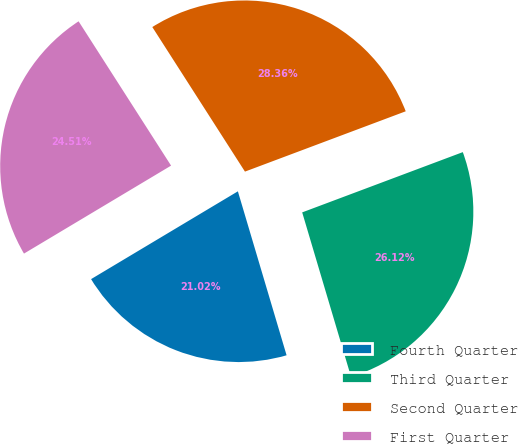Convert chart to OTSL. <chart><loc_0><loc_0><loc_500><loc_500><pie_chart><fcel>Fourth Quarter<fcel>Third Quarter<fcel>Second Quarter<fcel>First Quarter<nl><fcel>21.02%<fcel>26.12%<fcel>28.36%<fcel>24.51%<nl></chart> 